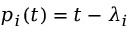<formula> <loc_0><loc_0><loc_500><loc_500>p _ { i } ( t ) = t - \lambda _ { i }</formula> 